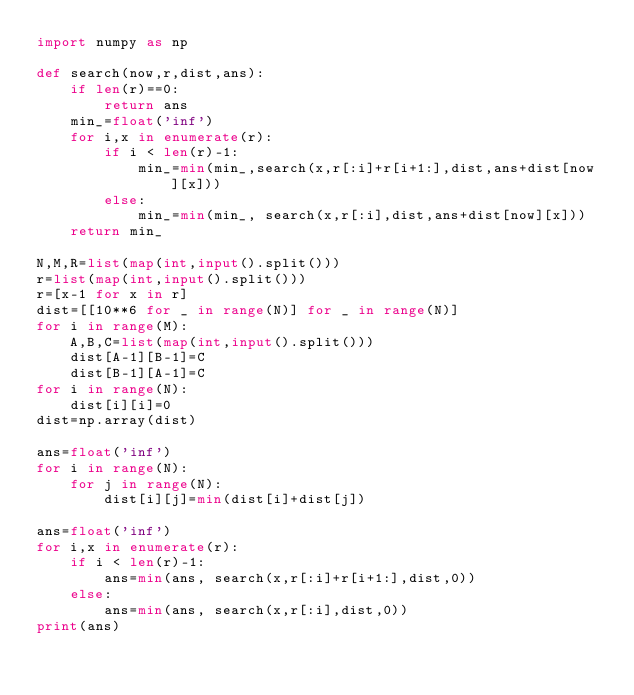<code> <loc_0><loc_0><loc_500><loc_500><_Python_>import numpy as np

def search(now,r,dist,ans):
    if len(r)==0:
        return ans
    min_=float('inf')
    for i,x in enumerate(r):
        if i < len(r)-1:
            min_=min(min_,search(x,r[:i]+r[i+1:],dist,ans+dist[now][x]))
        else:
            min_=min(min_, search(x,r[:i],dist,ans+dist[now][x]))
    return min_

N,M,R=list(map(int,input().split()))
r=list(map(int,input().split()))
r=[x-1 for x in r]
dist=[[10**6 for _ in range(N)] for _ in range(N)]
for i in range(M):
    A,B,C=list(map(int,input().split()))
    dist[A-1][B-1]=C
    dist[B-1][A-1]=C
for i in range(N):
    dist[i][i]=0
dist=np.array(dist)

ans=float('inf')
for i in range(N):
    for j in range(N):
        dist[i][j]=min(dist[i]+dist[j])

ans=float('inf')
for i,x in enumerate(r):
    if i < len(r)-1:
        ans=min(ans, search(x,r[:i]+r[i+1:],dist,0))
    else:
        ans=min(ans, search(x,r[:i],dist,0))
print(ans)</code> 